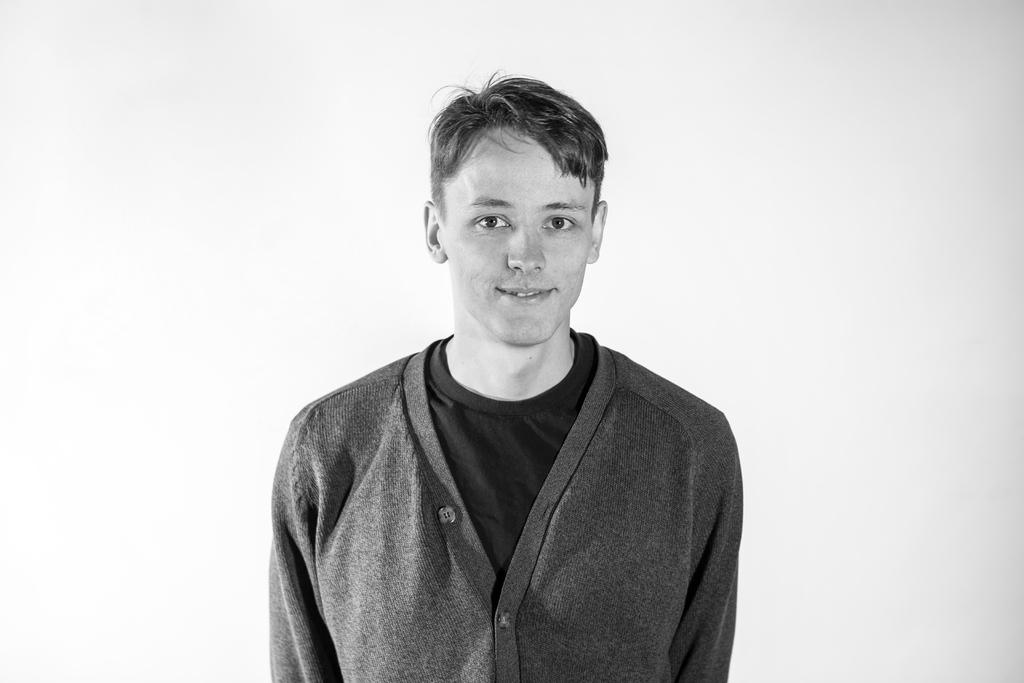What is the color scheme of the image? The image is black and white. Who is in the image? There is a man in the image. What is the man doing in the image? The man is standing and posing for the photo. What expression does the man have in the image? The man is smiling in the image. What can be seen behind the man in the image? The background of the man is plain. How many thumbs does the man have in the image? The image is black and white, and it does not provide enough detail to determine the number of thumbs the man has. What type of cannon is visible in the image? There is no cannon present in the image. 